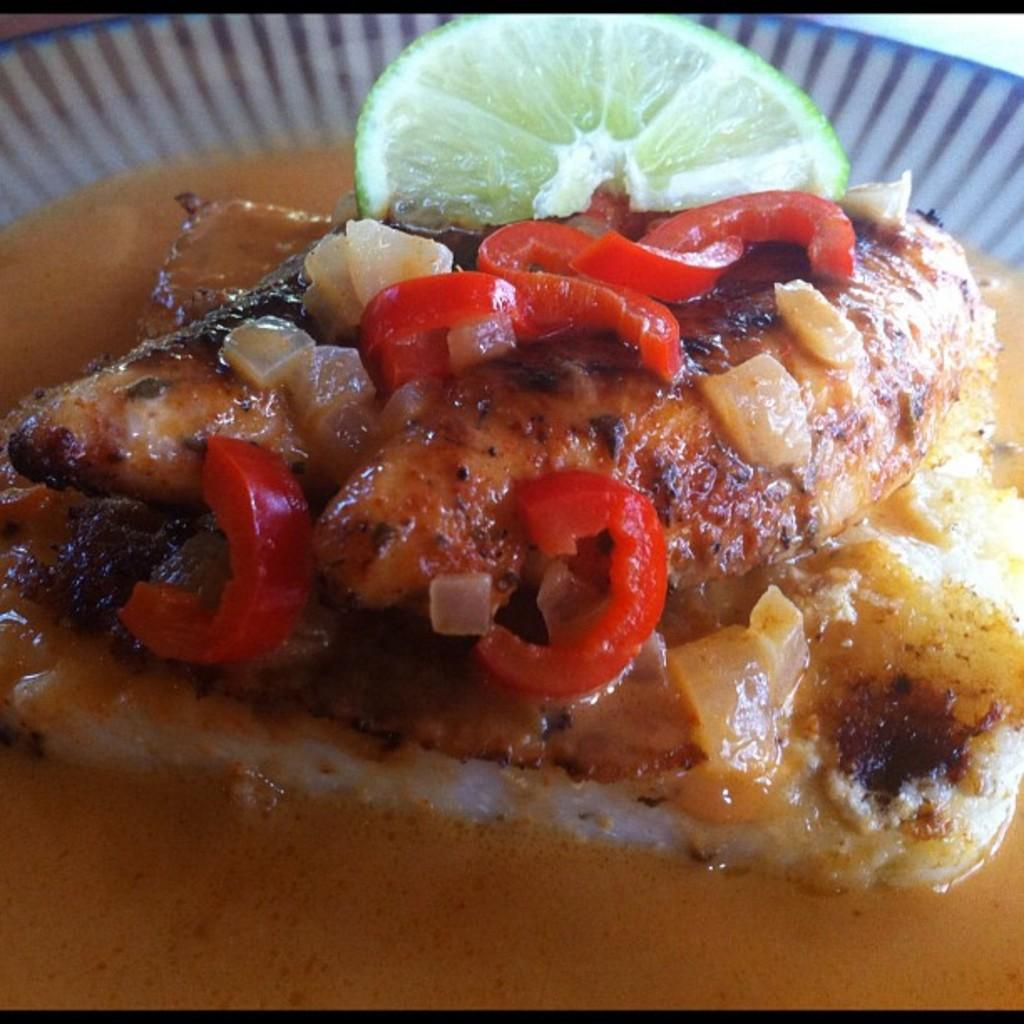What is on the plate in the image? There is food on a plate in the image. What type of relation does the food on the plate have with the cherries in the image? There are no cherries present in the image, so there is no relation between the food on the plate and cherries. 